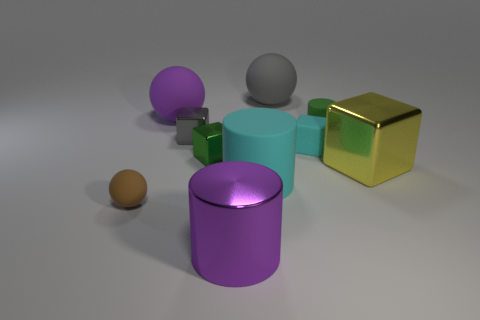Subtract all small cylinders. How many cylinders are left? 2 Subtract 0 cyan spheres. How many objects are left? 10 Subtract all cubes. How many objects are left? 6 Subtract 1 cylinders. How many cylinders are left? 2 Subtract all gray cylinders. Subtract all red cubes. How many cylinders are left? 3 Subtract all brown blocks. How many cyan cylinders are left? 1 Subtract all small matte spheres. Subtract all small green rubber cylinders. How many objects are left? 8 Add 3 large matte objects. How many large matte objects are left? 6 Add 6 large cyan things. How many large cyan things exist? 7 Subtract all green cylinders. How many cylinders are left? 2 